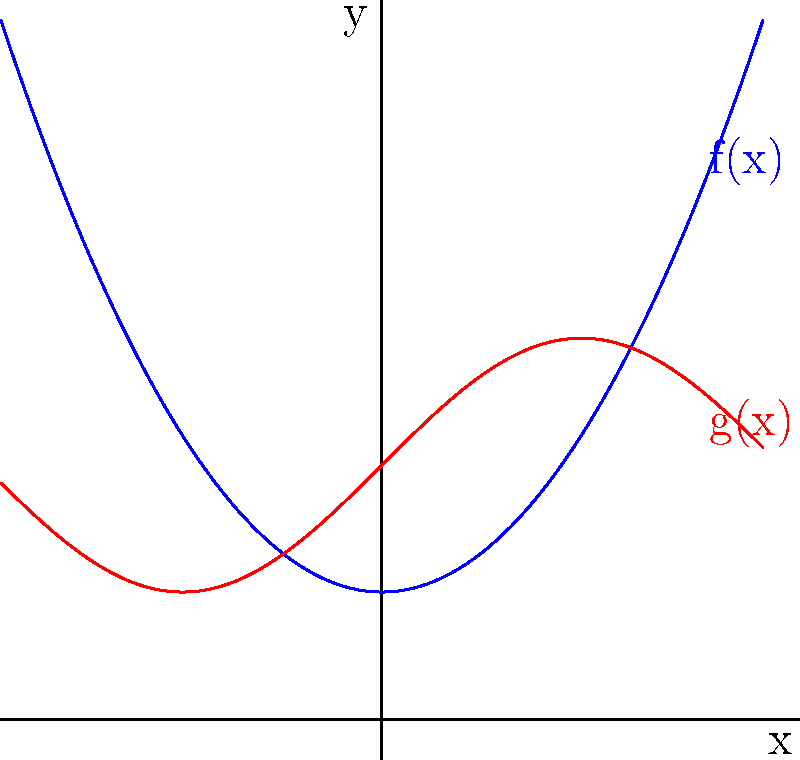Given two currency market trend functions $f(x)$ and $g(x)$ as shown in the graph, where $f(x) = 0.5x^2 + 1$ and $g(x) = \sin(x) + 2$, determine the composition $(f \circ g)(x)$ at $x = \frac{\pi}{2}$. To find $(f \circ g)(x)$ at $x = \frac{\pi}{2}$, we need to follow these steps:

1) The composition $(f \circ g)(x)$ means we first apply $g(x)$, then apply $f(x)$ to the result.

2) First, calculate $g(\frac{\pi}{2})$:
   $g(\frac{\pi}{2}) = \sin(\frac{\pi}{2}) + 2 = 1 + 2 = 3$

3) Now, we need to calculate $f(3)$, as this is the input we get from step 2:
   $f(3) = 0.5(3)^2 + 1 = 0.5(9) + 1 = 4.5 + 1 = 5.5$

Therefore, $(f \circ g)(\frac{\pi}{2}) = 5.5$
Answer: 5.5 